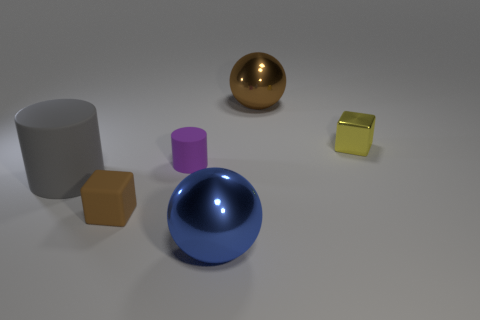Add 3 big gray objects. How many objects exist? 9 Subtract all cubes. How many objects are left? 4 Subtract 1 balls. How many balls are left? 1 Subtract 1 brown balls. How many objects are left? 5 Subtract all blue cylinders. Subtract all yellow cubes. How many cylinders are left? 2 Subtract all brown shiny cubes. Subtract all small metallic cubes. How many objects are left? 5 Add 4 brown blocks. How many brown blocks are left? 5 Add 5 tiny gray things. How many tiny gray things exist? 5 